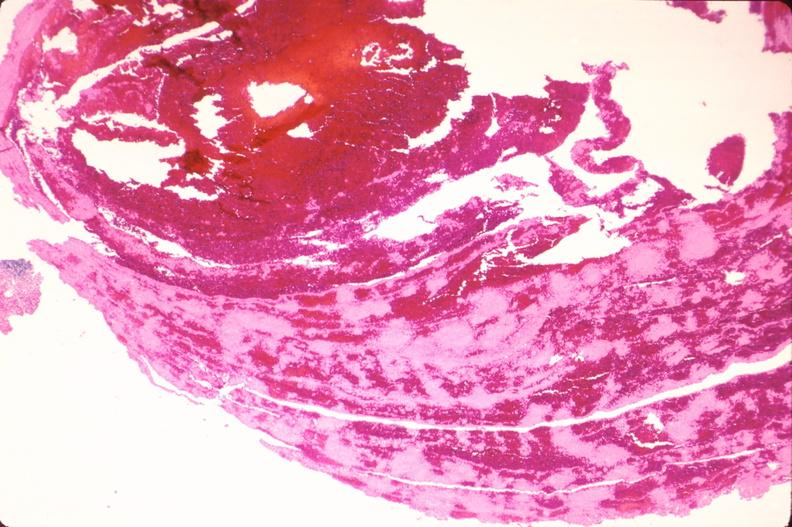s retroperitoneal leiomyosarcoma present?
Answer the question using a single word or phrase. No 